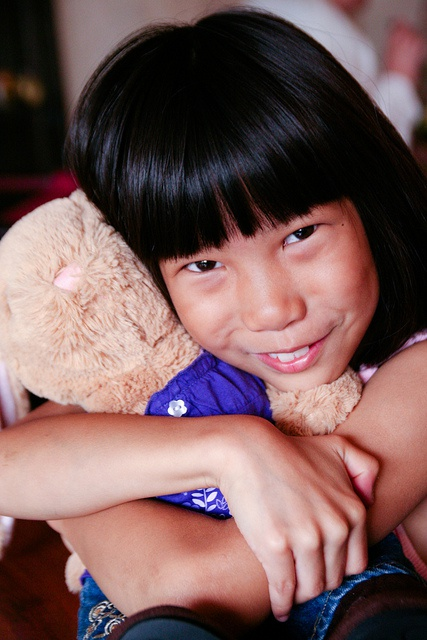Describe the objects in this image and their specific colors. I can see people in black, lightpink, brown, and lightgray tones, teddy bear in black, pink, lightgray, tan, and darkblue tones, and people in black, darkgray, and brown tones in this image. 